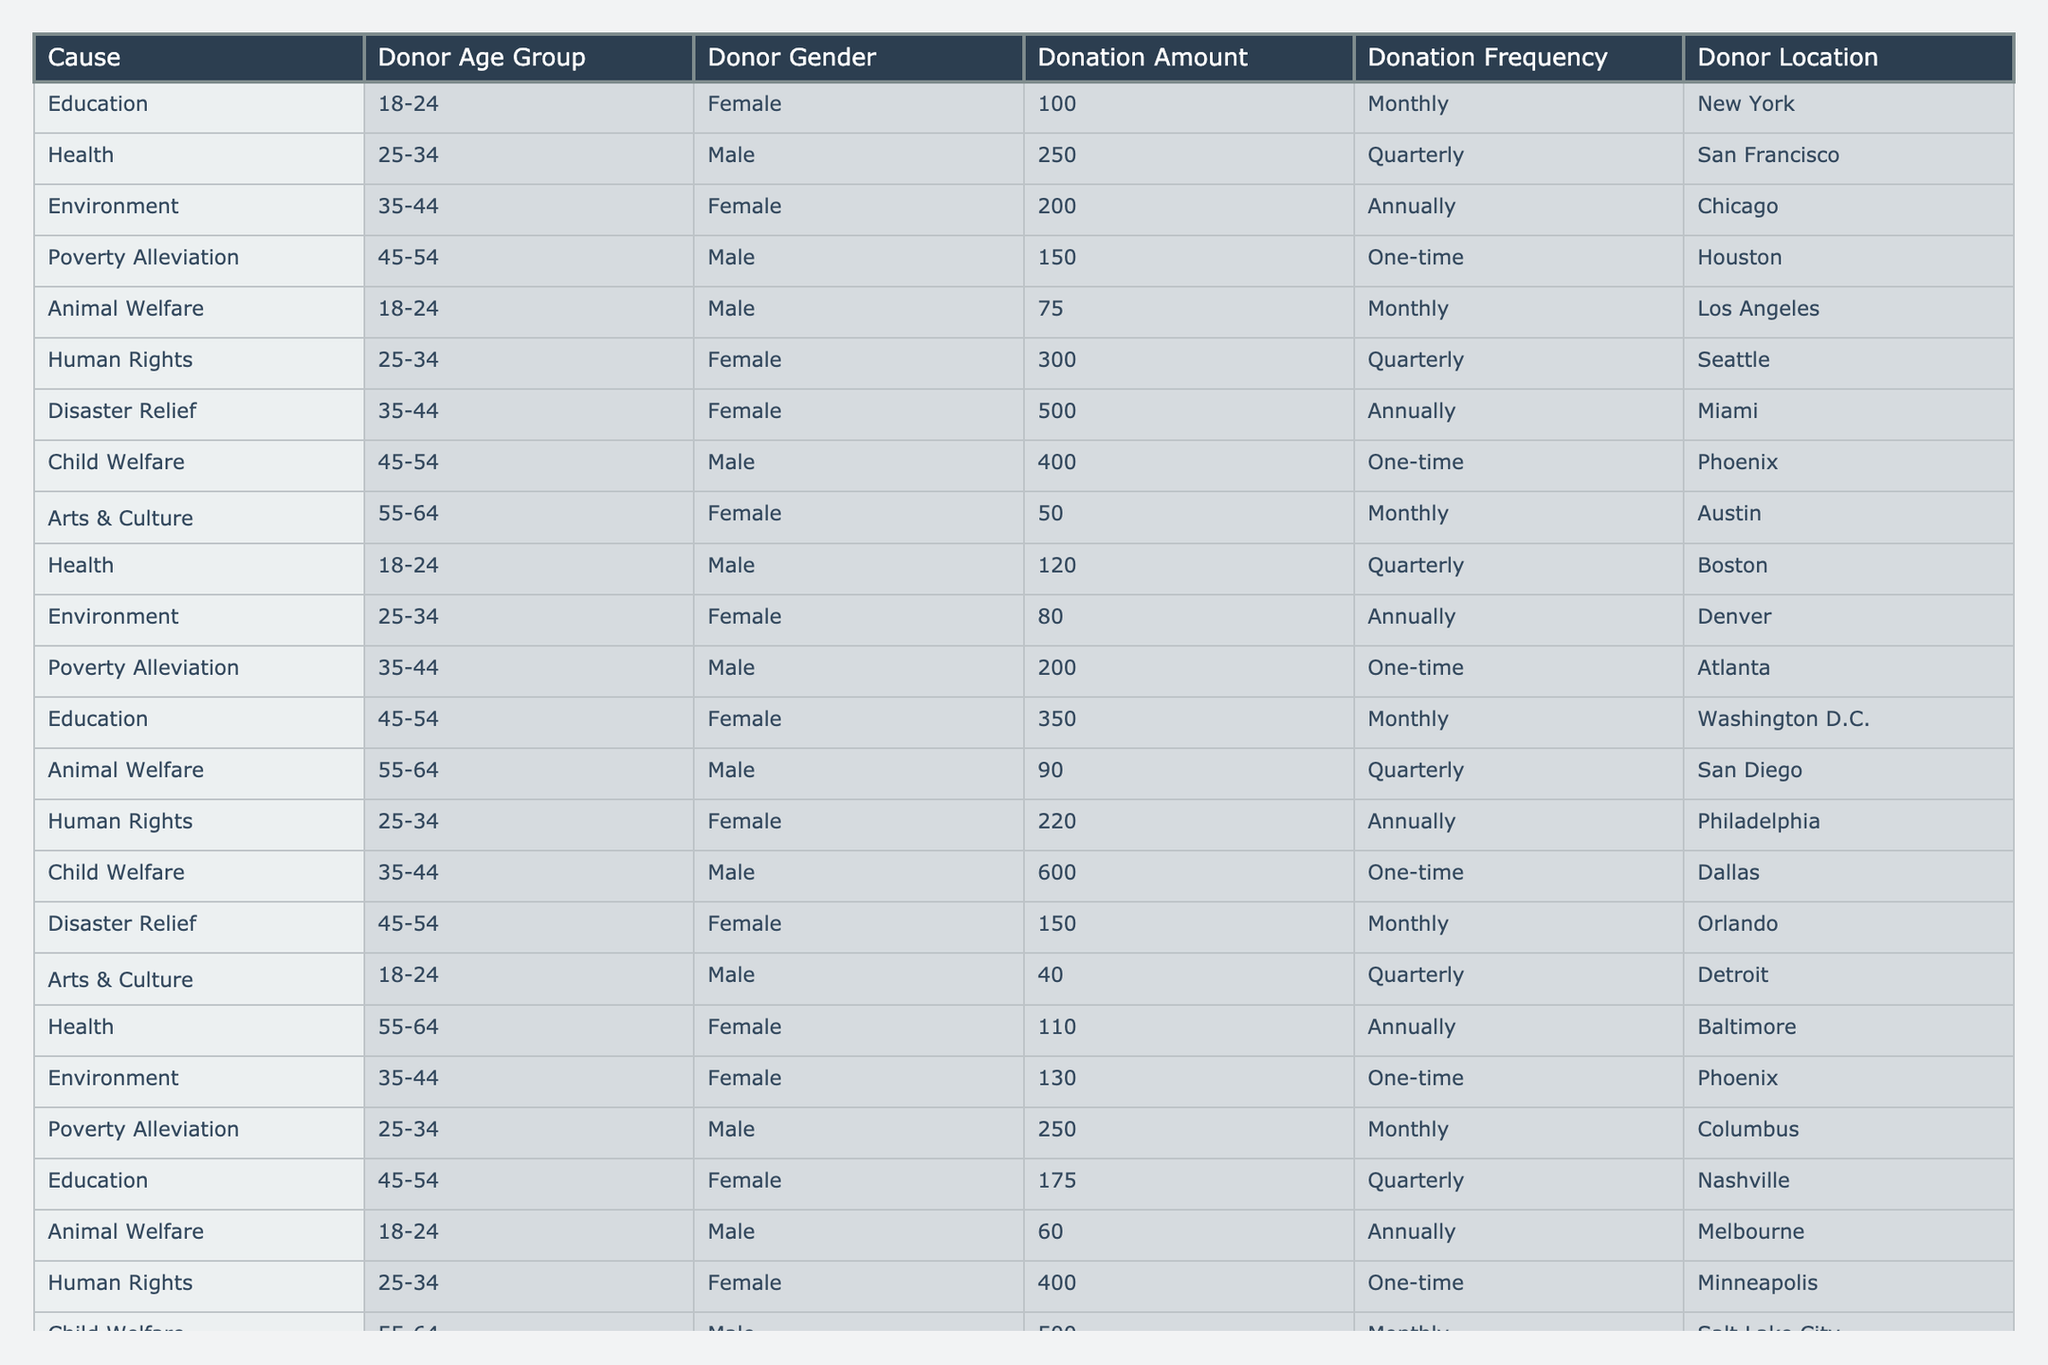What is the total donation amount for the "Health" cause? The table lists two donations under the "Health" cause: one for 250 and another for 120. To find the total, sum these amounts: 250 + 120 = 370.
Answer: 370 Which age group donated the largest single amount in the "Child Welfare" category? In the "Child Welfare" category, there are two entries: one from the age group 35-44 donating 600 and another from the age group 55-64 donating 500. The largest single amount is 600.
Answer: 35-44 How many female donors made contributions on a monthly basis? By checking the donation frequency for female donors from the table, there are contributions made monthly by females in "Education," "Disaster Relief," "Arts & Culture," and "Health," totaling four female donors.
Answer: 4 What is the average donation amount for the "Animal Welfare" cause? The "Animal Welfare" category has two donations: one for 75 and another for 90. To find the average, sum these amounts (75 + 90 = 165) and divide by the number of donations (2): 165 / 2 = 82.5.
Answer: 82.5 True or False: There are more one-time donations than monthly donations in total. Evaluating the table, there are 5 one-time donations (Poverty Alleviation, Child Welfare, Environment, Human Rights, and a second one in Child Welfare) and 6 monthly donations (Education, Animal Welfare, Disaster Relief, Arts & Culture, Health, and another in Child Welfare), so it’s False that there are more one-time donations.
Answer: False Which location has the highest single donation amount, and what was the amount? Reviewing the table, the highest single donation is 600 made for "Child Welfare" from Dallas.
Answer: Dallas, 600 What is the total donation frequency classified as "Quarterly" among all causes? The donations with the frequency "Quarterly" are from Health (250), Human Rights (220), Animal Welfare (90), Poverty Alleviation (250), and Disaster Relief (300). Adding these values gives 250 + 220 + 90 + 250 + 300 = 1110.
Answer: 1110 Which cause had the highest average donation amount across all age groups? Calculate the average donation for each cause: Education (225), Health (240), Environment (130), Poverty Alleviation (183.33), Animal Welfare (82.5), Human Rights (310), Disaster Relief (250), and Child Welfare (550). "Child Welfare" has the highest average of 550.
Answer: Child Welfare In which gender category did the most significant donation frequency occur? By counting donation frequencies, males contributed monthly 3 times (3 donations) while female donors in the same category donated 5 times (5 donations). Therefore, female donors had a greater donation frequency.
Answer: Female How many donations were made by donors in the age group of 45-54? In the 45-54 age group, there are four donations listed in the table: two in "Education" (350, 175), one in "Child Welfare" (400), and one in "Disaster Relief" (150). Thus, the total is 4 donations.
Answer: 4 